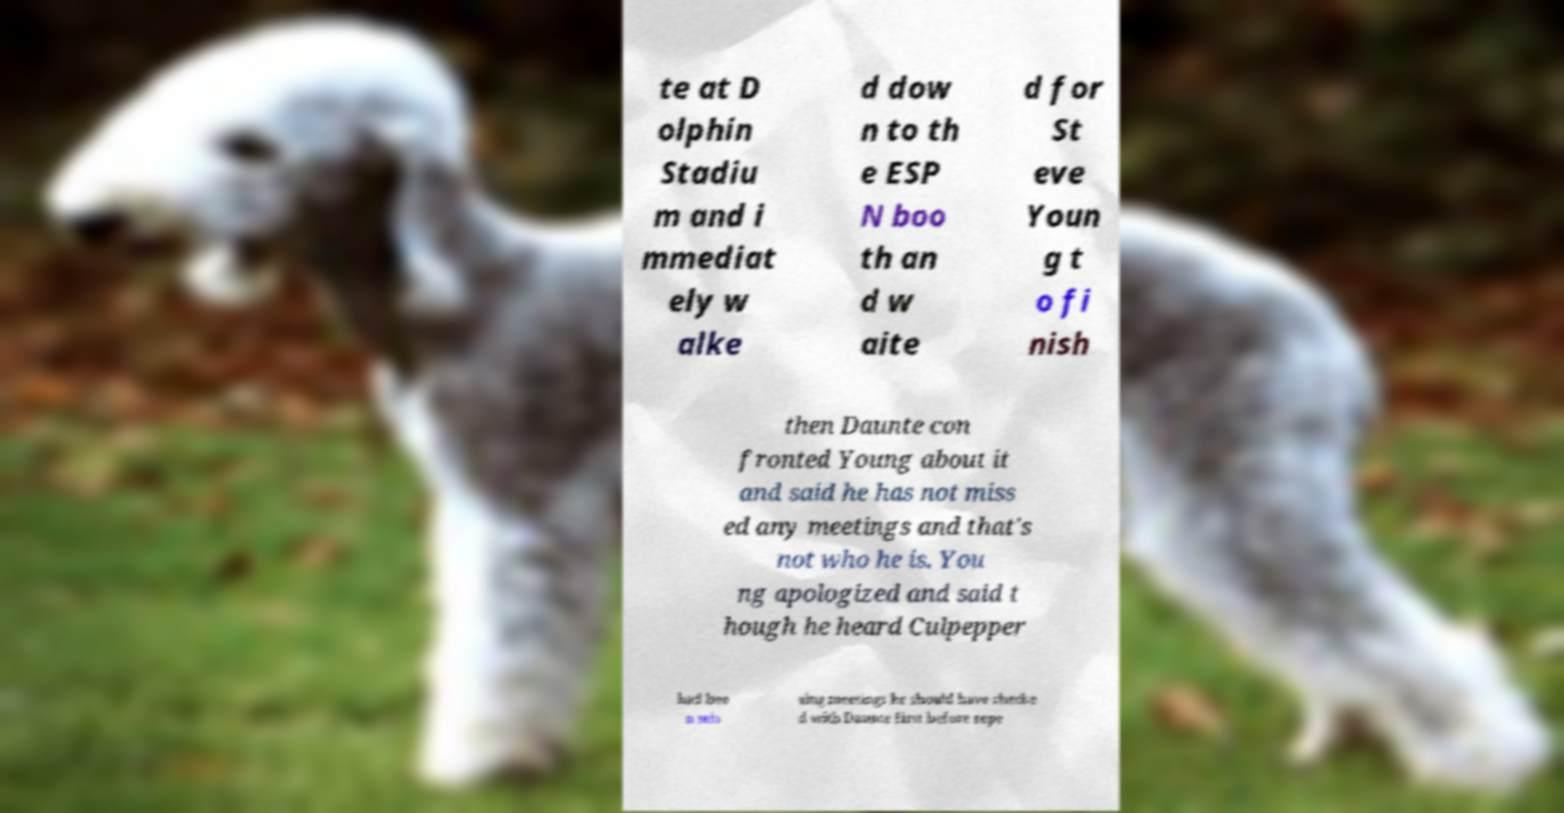For documentation purposes, I need the text within this image transcribed. Could you provide that? te at D olphin Stadiu m and i mmediat ely w alke d dow n to th e ESP N boo th an d w aite d for St eve Youn g t o fi nish then Daunte con fronted Young about it and said he has not miss ed any meetings and that's not who he is. You ng apologized and said t hough he heard Culpepper had bee n mis sing meetings he should have checke d with Daunte first before repe 